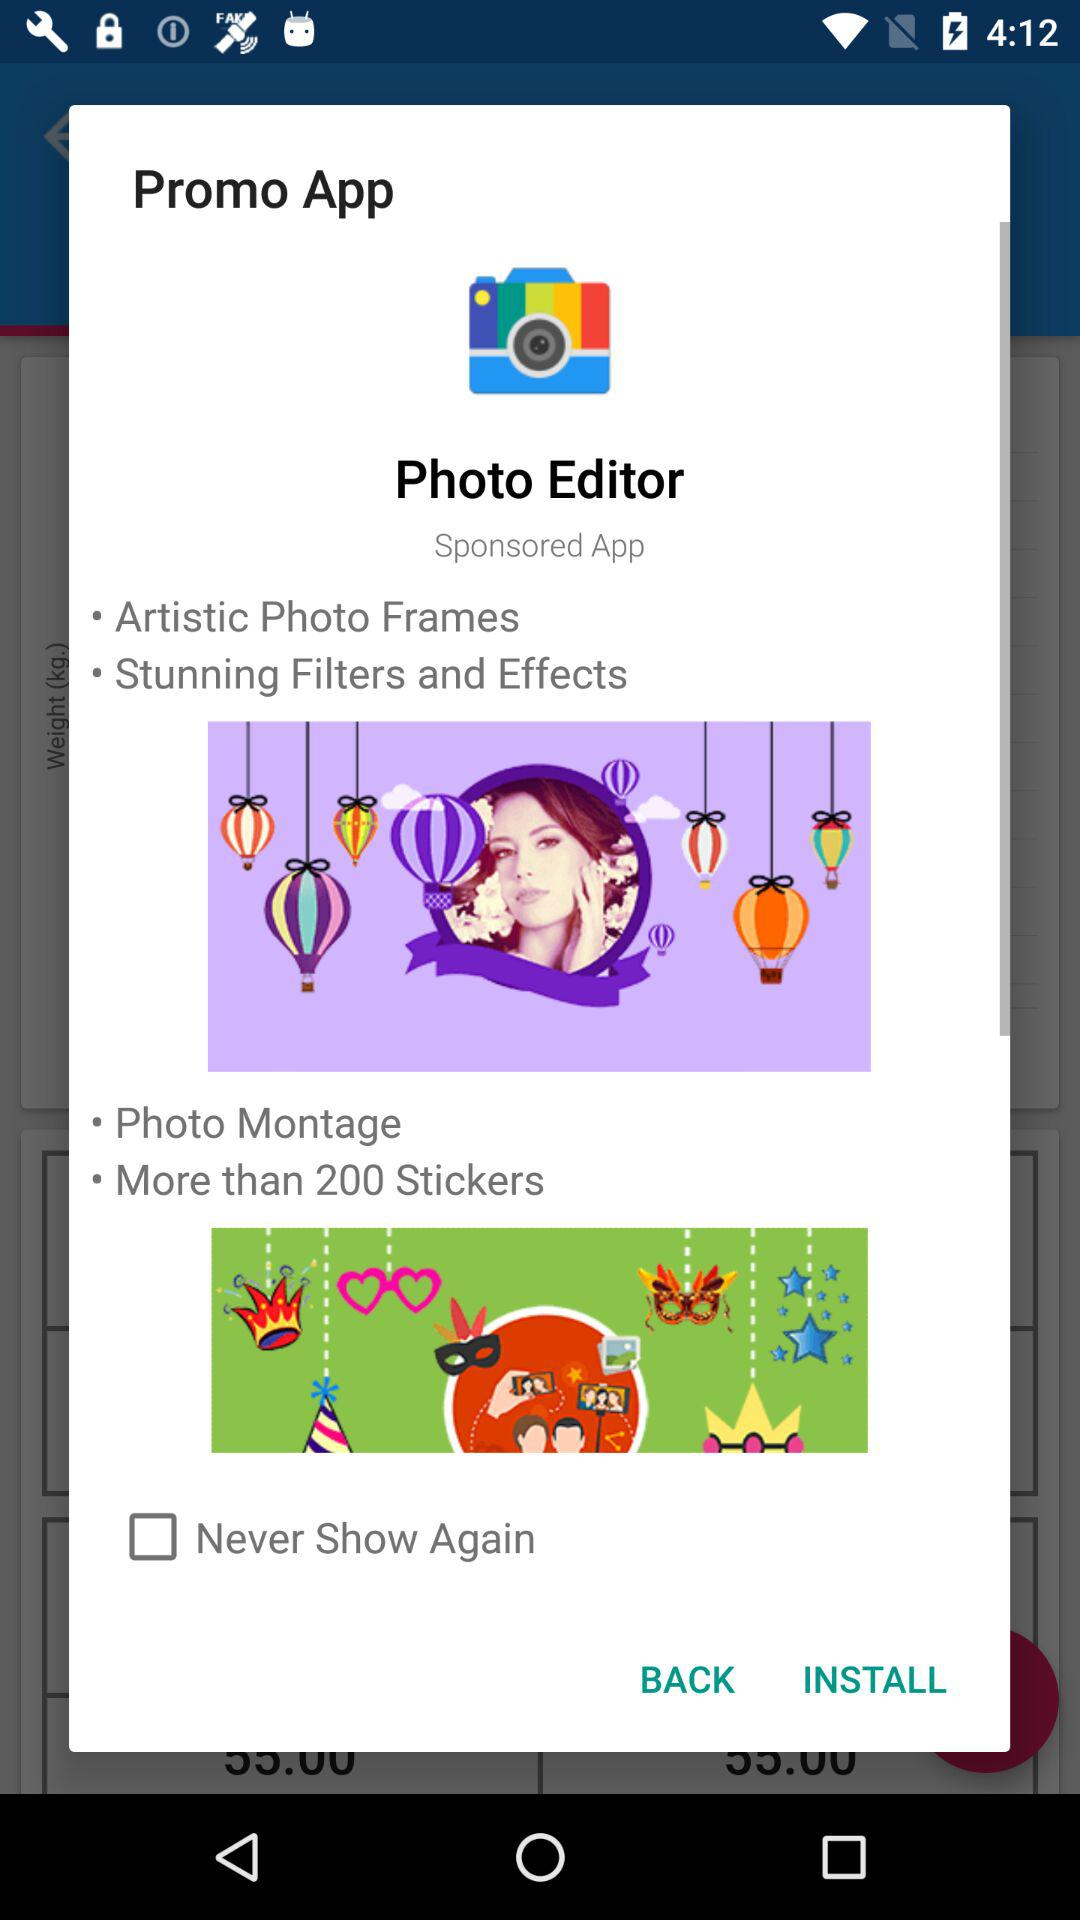What is the name of the application? The name of the application is "Photo Editor". 